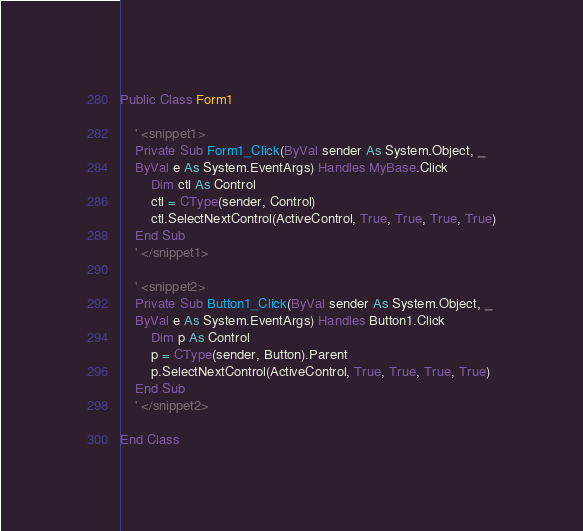Convert code to text. <code><loc_0><loc_0><loc_500><loc_500><_VisualBasic_>Public Class Form1

    ' <snippet1>
    Private Sub Form1_Click(ByVal sender As System.Object, _
    ByVal e As System.EventArgs) Handles MyBase.Click
        Dim ctl As Control
        ctl = CType(sender, Control)
        ctl.SelectNextControl(ActiveControl, True, True, True, True)
    End Sub
    ' </snippet1>

    ' <snippet2>
    Private Sub Button1_Click(ByVal sender As System.Object, _
    ByVal e As System.EventArgs) Handles Button1.Click
        Dim p As Control
        p = CType(sender, Button).Parent
        p.SelectNextControl(ActiveControl, True, True, True, True)
    End Sub
    ' </snippet2>

End Class
</code> 